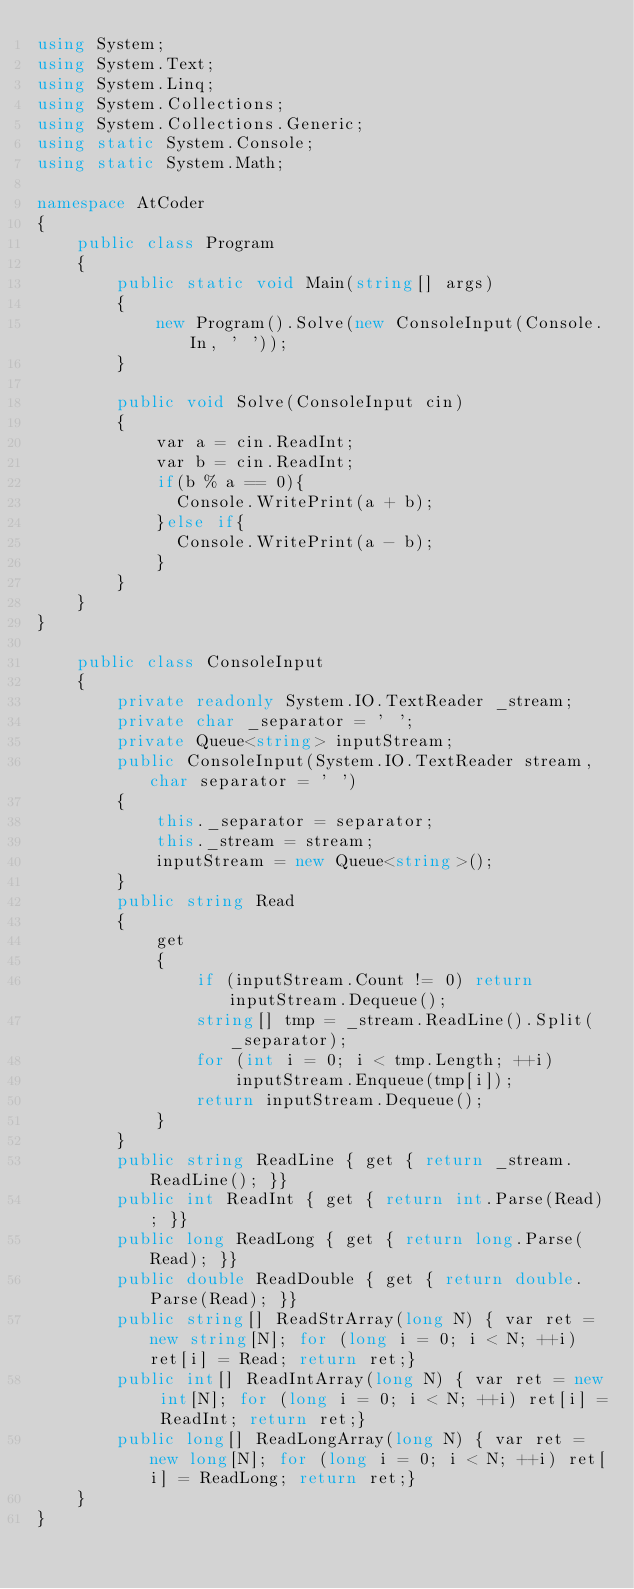<code> <loc_0><loc_0><loc_500><loc_500><_C#_>using System;
using System.Text;
using System.Linq;
using System.Collections;
using System.Collections.Generic;
using static System.Console;
using static System.Math;

namespace AtCoder
{
    public class Program
    {
        public static void Main(string[] args)
        {
            new Program().Solve(new ConsoleInput(Console.In, ' '));
        }

        public void Solve(ConsoleInput cin)
        {
            var a = cin.ReadInt;
            var b = cin.ReadInt;
            if(b % a == 0){
              Console.WritePrint(a + b);
            }else if{
              Console.WritePrint(a - b);
            }
        }
    }
}  

    public class ConsoleInput
    {
        private readonly System.IO.TextReader _stream;
        private char _separator = ' ';
        private Queue<string> inputStream;
        public ConsoleInput(System.IO.TextReader stream, char separator = ' ')
        {
            this._separator = separator;
            this._stream = stream;
            inputStream = new Queue<string>();
        }
        public string Read
        {
            get
            {
                if (inputStream.Count != 0) return inputStream.Dequeue();
                string[] tmp = _stream.ReadLine().Split(_separator);
                for (int i = 0; i < tmp.Length; ++i)
                    inputStream.Enqueue(tmp[i]);
                return inputStream.Dequeue();
            }
        }
        public string ReadLine { get { return _stream.ReadLine(); }}
        public int ReadInt { get { return int.Parse(Read); }}
        public long ReadLong { get { return long.Parse(Read); }}
        public double ReadDouble { get { return double.Parse(Read); }}
        public string[] ReadStrArray(long N) { var ret = new string[N]; for (long i = 0; i < N; ++i) ret[i] = Read; return ret;}
        public int[] ReadIntArray(long N) { var ret = new int[N]; for (long i = 0; i < N; ++i) ret[i] = ReadInt; return ret;}
        public long[] ReadLongArray(long N) { var ret = new long[N]; for (long i = 0; i < N; ++i) ret[i] = ReadLong; return ret;}
    }
}
</code> 